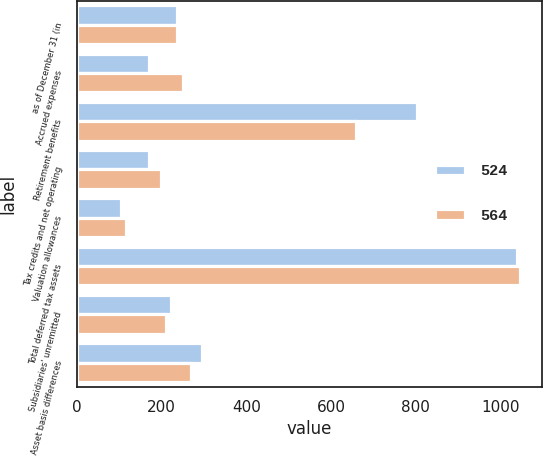Convert chart to OTSL. <chart><loc_0><loc_0><loc_500><loc_500><stacked_bar_chart><ecel><fcel>as of December 31 (in<fcel>Accrued expenses<fcel>Retirement benefits<fcel>Tax credits and net operating<fcel>Valuation allowances<fcel>Total deferred tax assets<fcel>Subsidiaries' unremitted<fcel>Asset basis differences<nl><fcel>524<fcel>236.5<fcel>171<fcel>804<fcel>169<fcel>104<fcel>1040<fcel>222<fcel>294<nl><fcel>564<fcel>236.5<fcel>251<fcel>658<fcel>198<fcel>116<fcel>1045<fcel>211<fcel>270<nl></chart> 